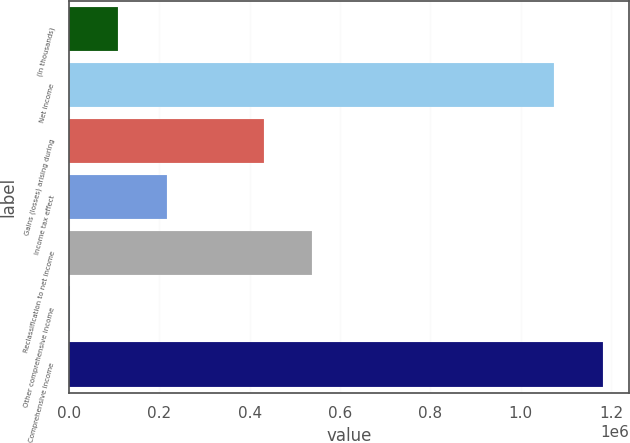<chart> <loc_0><loc_0><loc_500><loc_500><bar_chart><fcel>(In thousands)<fcel>Net income<fcel>Gains (losses) arising during<fcel>Income tax effect<fcel>Reclassification to net income<fcel>Other comprehensive income<fcel>Comprehensive income<nl><fcel>109170<fcel>1.07411e+06<fcel>431401<fcel>216580<fcel>538812<fcel>1759<fcel>1.18152e+06<nl></chart> 